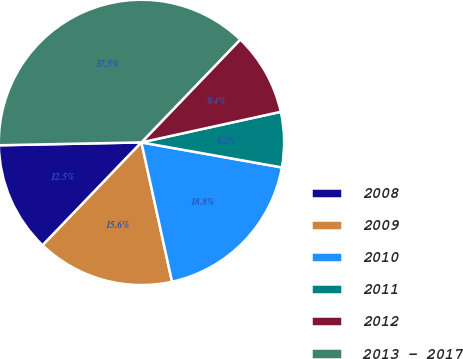Convert chart to OTSL. <chart><loc_0><loc_0><loc_500><loc_500><pie_chart><fcel>2008<fcel>2009<fcel>2010<fcel>2011<fcel>2012<fcel>2013 - 2017<nl><fcel>12.5%<fcel>15.62%<fcel>18.75%<fcel>6.25%<fcel>9.38%<fcel>37.5%<nl></chart> 